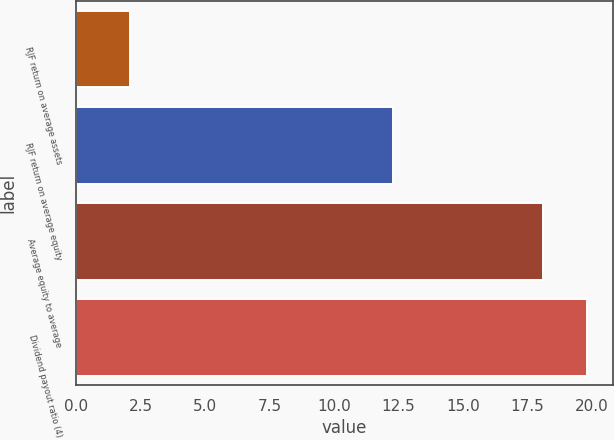Convert chart to OTSL. <chart><loc_0><loc_0><loc_500><loc_500><bar_chart><fcel>RJF return on average assets<fcel>RJF return on average equity<fcel>Average equity to average<fcel>Dividend payout ratio (4)<nl><fcel>2.1<fcel>12.3<fcel>18.1<fcel>19.82<nl></chart> 